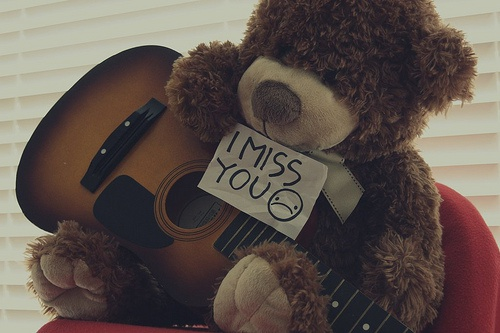Describe the objects in this image and their specific colors. I can see teddy bear in darkgray, black, gray, and maroon tones and tie in darkgray, gray, and black tones in this image. 